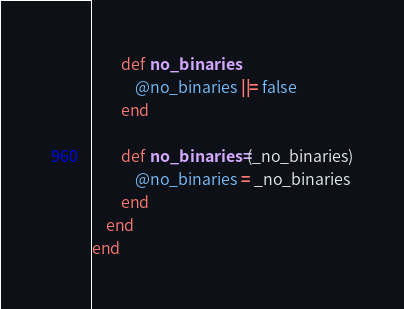<code> <loc_0><loc_0><loc_500><loc_500><_Ruby_>		def no_binaries 
			@no_binaries ||= false
		end

		def no_binaries=(_no_binaries)
			@no_binaries = _no_binaries
		end
	end
end</code> 